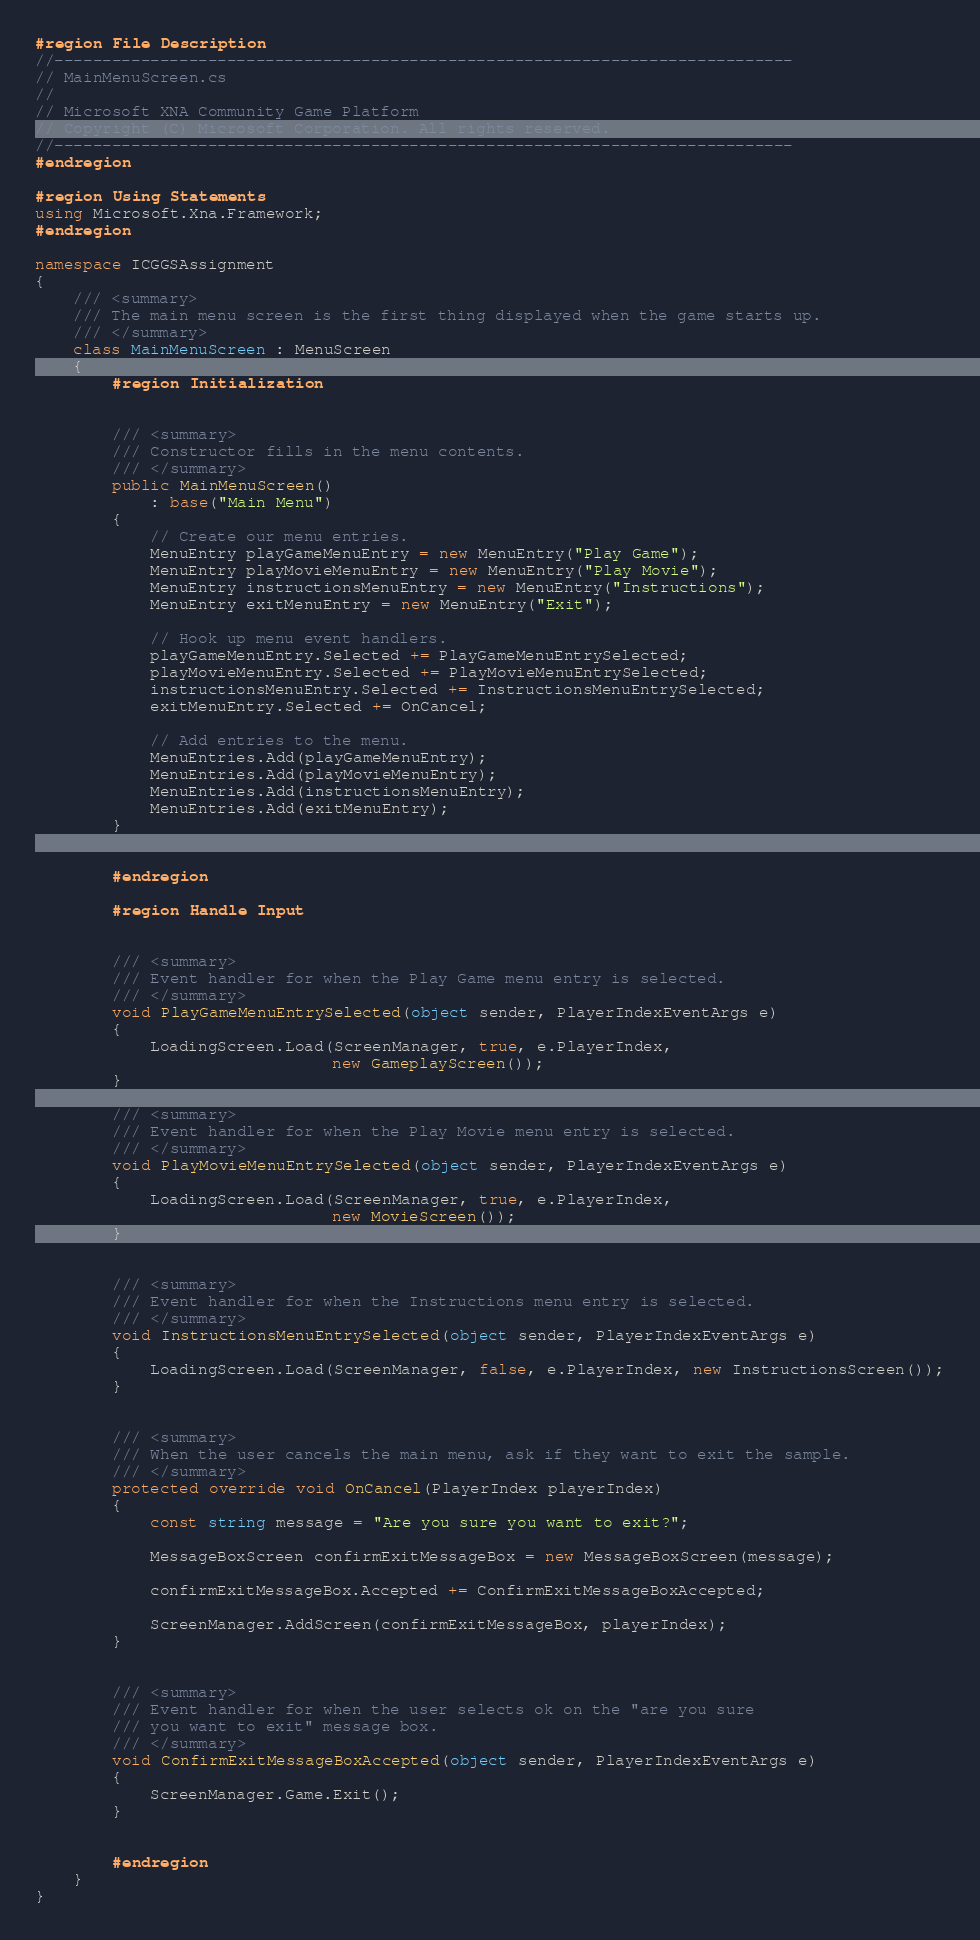<code> <loc_0><loc_0><loc_500><loc_500><_C#_>#region File Description
//-----------------------------------------------------------------------------
// MainMenuScreen.cs
//
// Microsoft XNA Community Game Platform
// Copyright (C) Microsoft Corporation. All rights reserved.
//-----------------------------------------------------------------------------
#endregion

#region Using Statements
using Microsoft.Xna.Framework;
#endregion

namespace ICGGSAssignment
{
    /// <summary>
    /// The main menu screen is the first thing displayed when the game starts up.
    /// </summary>
    class MainMenuScreen : MenuScreen
    {
        #region Initialization


        /// <summary>
        /// Constructor fills in the menu contents.
        /// </summary>
        public MainMenuScreen()
            : base("Main Menu")
        {
            // Create our menu entries.
            MenuEntry playGameMenuEntry = new MenuEntry("Play Game");
            MenuEntry playMovieMenuEntry = new MenuEntry("Play Movie");
            MenuEntry instructionsMenuEntry = new MenuEntry("Instructions");
            MenuEntry exitMenuEntry = new MenuEntry("Exit");

            // Hook up menu event handlers.
            playGameMenuEntry.Selected += PlayGameMenuEntrySelected;
            playMovieMenuEntry.Selected += PlayMovieMenuEntrySelected;
            instructionsMenuEntry.Selected += InstructionsMenuEntrySelected;
            exitMenuEntry.Selected += OnCancel;

            // Add entries to the menu.
            MenuEntries.Add(playGameMenuEntry);
            MenuEntries.Add(playMovieMenuEntry);
            MenuEntries.Add(instructionsMenuEntry);
            MenuEntries.Add(exitMenuEntry);
        }


        #endregion

        #region Handle Input


        /// <summary>
        /// Event handler for when the Play Game menu entry is selected.
        /// </summary>
        void PlayGameMenuEntrySelected(object sender, PlayerIndexEventArgs e)
        {
            LoadingScreen.Load(ScreenManager, true, e.PlayerIndex,
                               new GameplayScreen());
        }

        /// <summary>
        /// Event handler for when the Play Movie menu entry is selected.
        /// </summary>
        void PlayMovieMenuEntrySelected(object sender, PlayerIndexEventArgs e)
        {
            LoadingScreen.Load(ScreenManager, true, e.PlayerIndex,
                               new MovieScreen());
        }


        /// <summary>
        /// Event handler for when the Instructions menu entry is selected.
        /// </summary>
        void InstructionsMenuEntrySelected(object sender, PlayerIndexEventArgs e)
        {
            LoadingScreen.Load(ScreenManager, false, e.PlayerIndex, new InstructionsScreen());
        }


        /// <summary>
        /// When the user cancels the main menu, ask if they want to exit the sample.
        /// </summary>
        protected override void OnCancel(PlayerIndex playerIndex)
        {
            const string message = "Are you sure you want to exit?";

            MessageBoxScreen confirmExitMessageBox = new MessageBoxScreen(message);

            confirmExitMessageBox.Accepted += ConfirmExitMessageBoxAccepted;

            ScreenManager.AddScreen(confirmExitMessageBox, playerIndex);
        }


        /// <summary>
        /// Event handler for when the user selects ok on the "are you sure
        /// you want to exit" message box.
        /// </summary>
        void ConfirmExitMessageBoxAccepted(object sender, PlayerIndexEventArgs e)
        {
            ScreenManager.Game.Exit();
        }


        #endregion
    }
}
</code> 